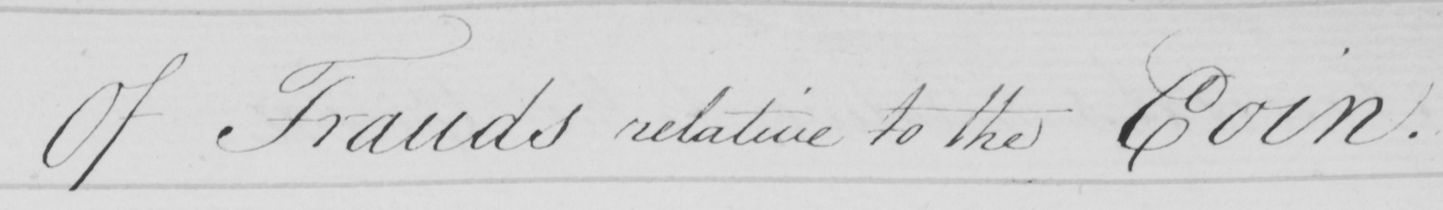Please transcribe the handwritten text in this image. Of Frauds relative to the Coin . 